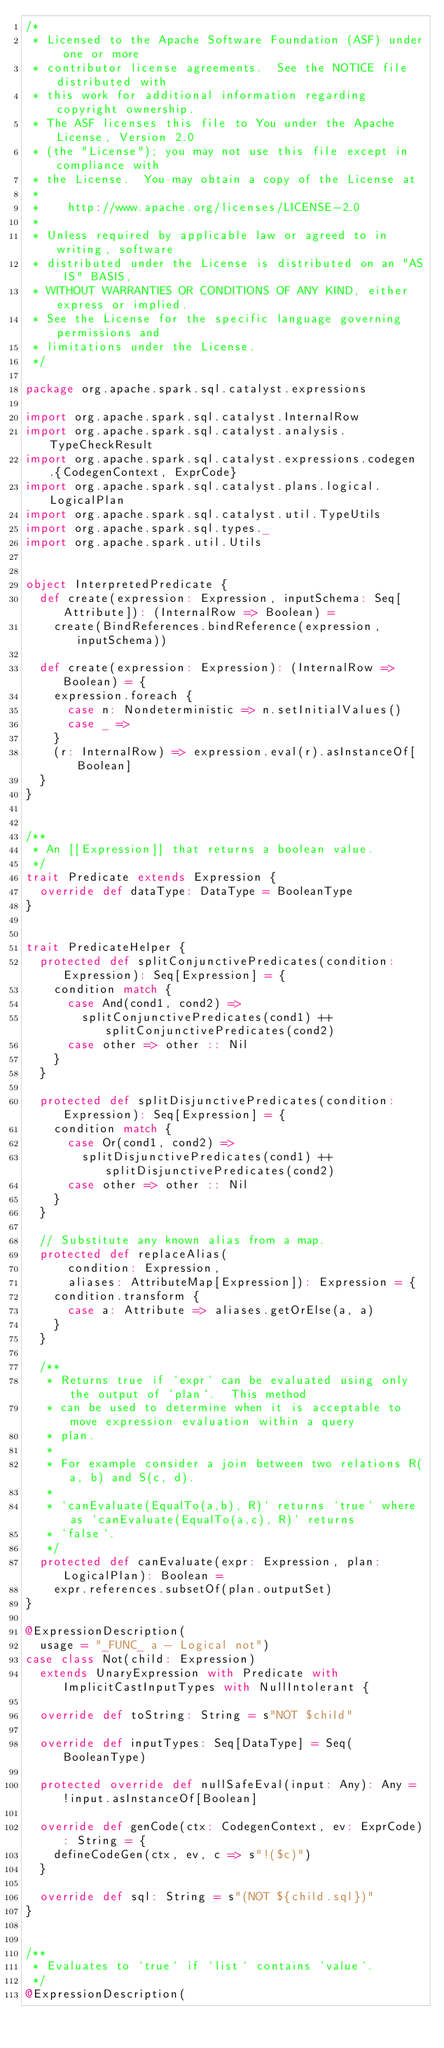Convert code to text. <code><loc_0><loc_0><loc_500><loc_500><_Scala_>/*
 * Licensed to the Apache Software Foundation (ASF) under one or more
 * contributor license agreements.  See the NOTICE file distributed with
 * this work for additional information regarding copyright ownership.
 * The ASF licenses this file to You under the Apache License, Version 2.0
 * (the "License"); you may not use this file except in compliance with
 * the License.  You may obtain a copy of the License at
 *
 *    http://www.apache.org/licenses/LICENSE-2.0
 *
 * Unless required by applicable law or agreed to in writing, software
 * distributed under the License is distributed on an "AS IS" BASIS,
 * WITHOUT WARRANTIES OR CONDITIONS OF ANY KIND, either express or implied.
 * See the License for the specific language governing permissions and
 * limitations under the License.
 */

package org.apache.spark.sql.catalyst.expressions

import org.apache.spark.sql.catalyst.InternalRow
import org.apache.spark.sql.catalyst.analysis.TypeCheckResult
import org.apache.spark.sql.catalyst.expressions.codegen.{CodegenContext, ExprCode}
import org.apache.spark.sql.catalyst.plans.logical.LogicalPlan
import org.apache.spark.sql.catalyst.util.TypeUtils
import org.apache.spark.sql.types._
import org.apache.spark.util.Utils


object InterpretedPredicate {
  def create(expression: Expression, inputSchema: Seq[Attribute]): (InternalRow => Boolean) =
    create(BindReferences.bindReference(expression, inputSchema))

  def create(expression: Expression): (InternalRow => Boolean) = {
    expression.foreach {
      case n: Nondeterministic => n.setInitialValues()
      case _ =>
    }
    (r: InternalRow) => expression.eval(r).asInstanceOf[Boolean]
  }
}


/**
 * An [[Expression]] that returns a boolean value.
 */
trait Predicate extends Expression {
  override def dataType: DataType = BooleanType
}


trait PredicateHelper {
  protected def splitConjunctivePredicates(condition: Expression): Seq[Expression] = {
    condition match {
      case And(cond1, cond2) =>
        splitConjunctivePredicates(cond1) ++ splitConjunctivePredicates(cond2)
      case other => other :: Nil
    }
  }

  protected def splitDisjunctivePredicates(condition: Expression): Seq[Expression] = {
    condition match {
      case Or(cond1, cond2) =>
        splitDisjunctivePredicates(cond1) ++ splitDisjunctivePredicates(cond2)
      case other => other :: Nil
    }
  }

  // Substitute any known alias from a map.
  protected def replaceAlias(
      condition: Expression,
      aliases: AttributeMap[Expression]): Expression = {
    condition.transform {
      case a: Attribute => aliases.getOrElse(a, a)
    }
  }

  /**
   * Returns true if `expr` can be evaluated using only the output of `plan`.  This method
   * can be used to determine when it is acceptable to move expression evaluation within a query
   * plan.
   *
   * For example consider a join between two relations R(a, b) and S(c, d).
   *
   * `canEvaluate(EqualTo(a,b), R)` returns `true` where as `canEvaluate(EqualTo(a,c), R)` returns
   * `false`.
   */
  protected def canEvaluate(expr: Expression, plan: LogicalPlan): Boolean =
    expr.references.subsetOf(plan.outputSet)
}

@ExpressionDescription(
  usage = "_FUNC_ a - Logical not")
case class Not(child: Expression)
  extends UnaryExpression with Predicate with ImplicitCastInputTypes with NullIntolerant {

  override def toString: String = s"NOT $child"

  override def inputTypes: Seq[DataType] = Seq(BooleanType)

  protected override def nullSafeEval(input: Any): Any = !input.asInstanceOf[Boolean]

  override def genCode(ctx: CodegenContext, ev: ExprCode): String = {
    defineCodeGen(ctx, ev, c => s"!($c)")
  }

  override def sql: String = s"(NOT ${child.sql})"
}


/**
 * Evaluates to `true` if `list` contains `value`.
 */
@ExpressionDescription(</code> 